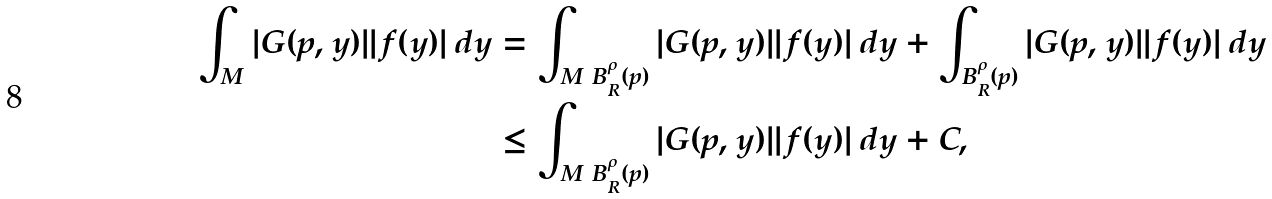Convert formula to latex. <formula><loc_0><loc_0><loc_500><loc_500>\int _ { M } | G ( p , y ) | | f ( y ) | \, d y & = \int _ { M \ B ^ { \rho } _ { R } ( p ) } | G ( p , y ) | | f ( y ) | \, d y + \int _ { B ^ { \rho } _ { R } ( p ) } | G ( p , y ) | | f ( y ) | \, d y \\ & \leq \int _ { M \ B ^ { \rho } _ { R } ( p ) } | G ( p , y ) | | f ( y ) | \, d y + C ,</formula> 